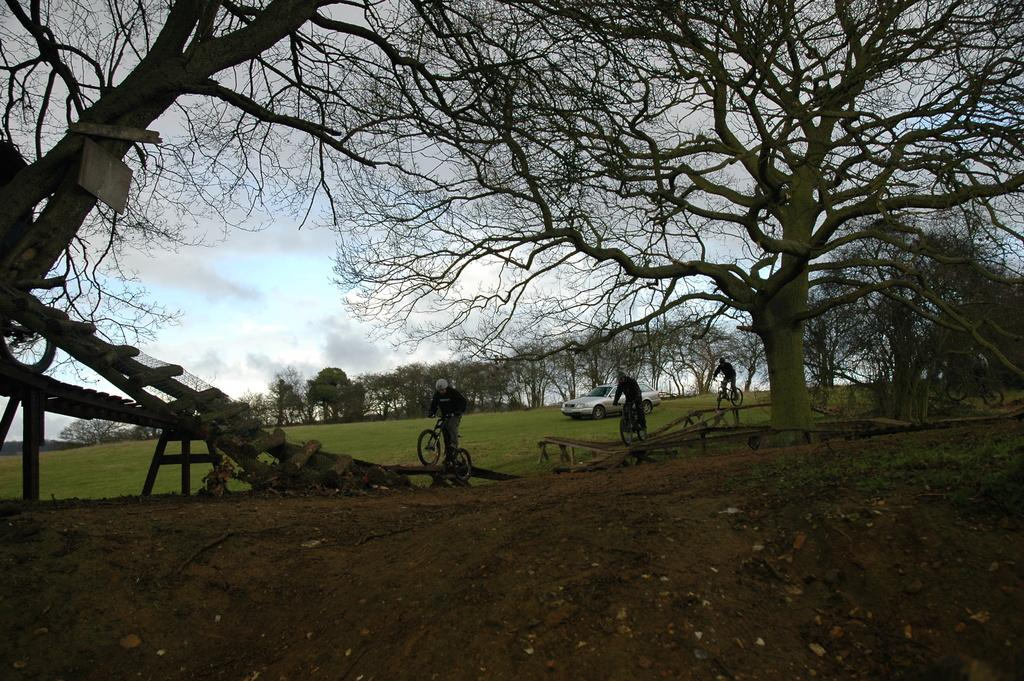What are the people in the image doing? The people in the image are riding bicycles. What else can be seen on the ground in the image? There is a car on the grass ground in the image. What type of natural environment is visible in the image? There are trees visible in the image. What type of harmony can be heard in the image? There is no audible sound in the image, so it is not possible to determine what type of harmony might be heard. 